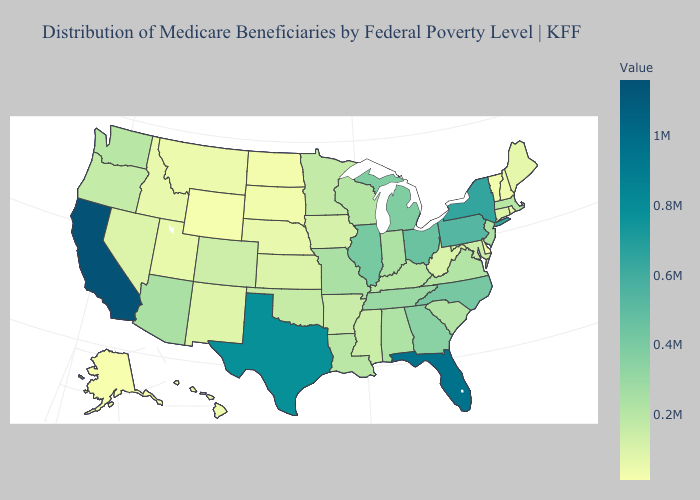Among the states that border Iowa , which have the lowest value?
Quick response, please. South Dakota. Does Hawaii have a lower value than Oregon?
Concise answer only. Yes. Which states hav the highest value in the MidWest?
Be succinct. Ohio. 